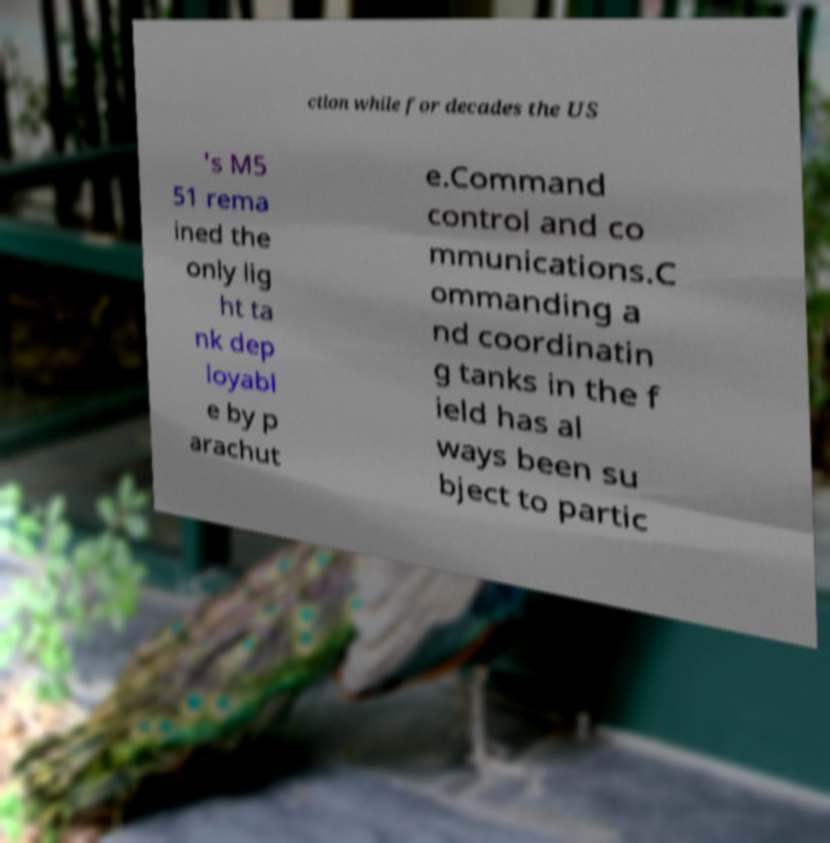Could you assist in decoding the text presented in this image and type it out clearly? ction while for decades the US 's M5 51 rema ined the only lig ht ta nk dep loyabl e by p arachut e.Command control and co mmunications.C ommanding a nd coordinatin g tanks in the f ield has al ways been su bject to partic 